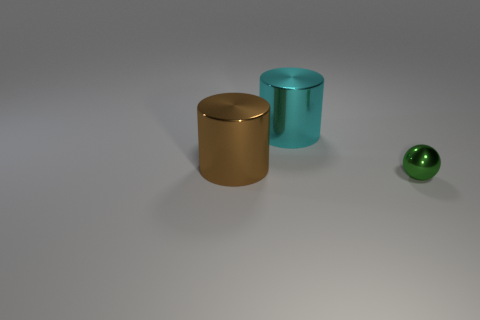Add 2 metal spheres. How many objects exist? 5 Subtract 0 yellow spheres. How many objects are left? 3 Subtract all cylinders. How many objects are left? 1 Subtract all red cylinders. Subtract all yellow cubes. How many cylinders are left? 2 Subtract all brown matte balls. Subtract all green things. How many objects are left? 2 Add 3 green balls. How many green balls are left? 4 Add 1 cylinders. How many cylinders exist? 3 